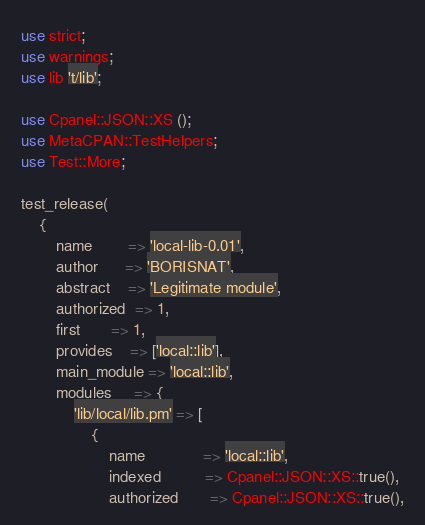Convert code to text. <code><loc_0><loc_0><loc_500><loc_500><_Perl_>use strict;
use warnings;
use lib 't/lib';

use Cpanel::JSON::XS ();
use MetaCPAN::TestHelpers;
use Test::More;

test_release(
    {
        name        => 'local-lib-0.01',
        author      => 'BORISNAT',
        abstract    => 'Legitimate module',
        authorized  => 1,
        first       => 1,
        provides    => ['local::lib'],
        main_module => 'local::lib',
        modules     => {
            'lib/local/lib.pm' => [
                {
                    name             => 'local::lib',
                    indexed          => Cpanel::JSON::XS::true(),
                    authorized       => Cpanel::JSON::XS::true(),</code> 